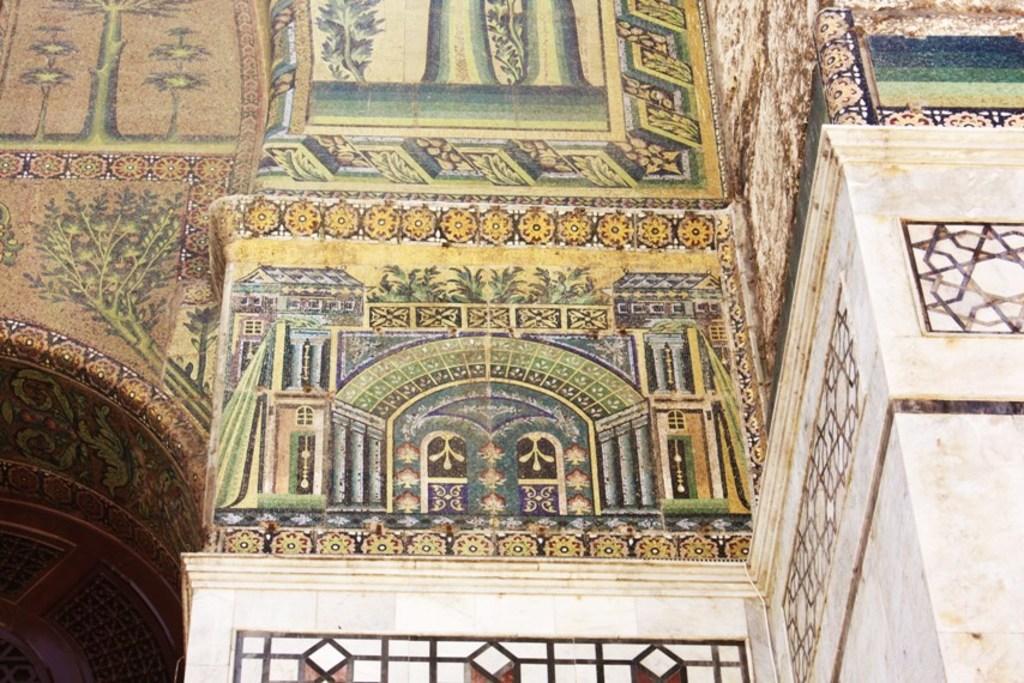How would you summarize this image in a sentence or two? In this image we can see the wall, with some paintings on it. 